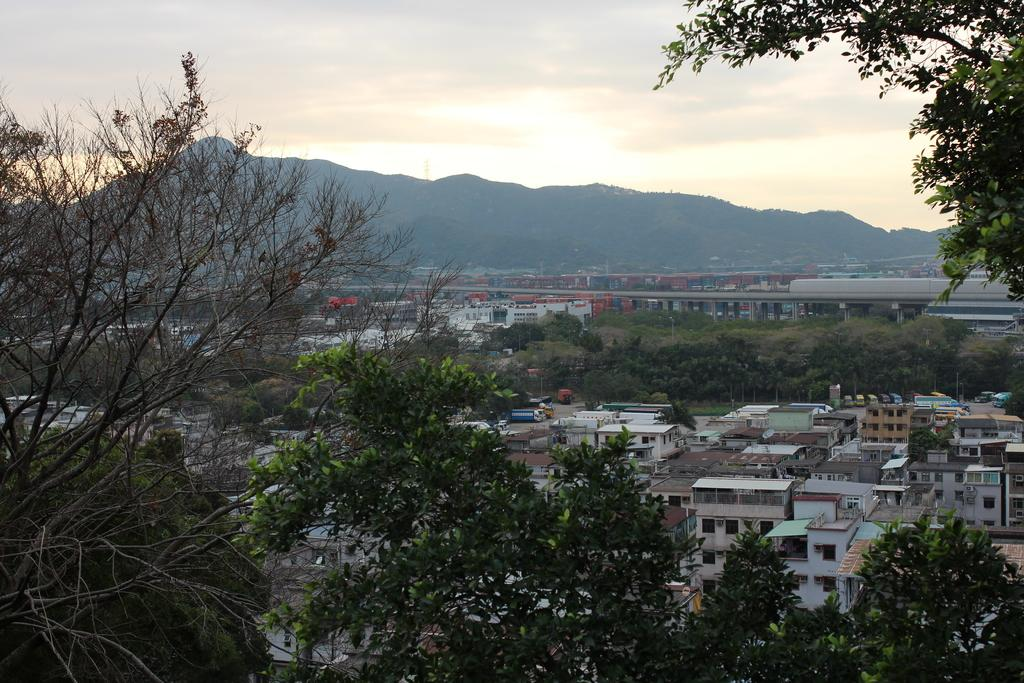What type of natural elements can be seen in the image? There are trees in the image. What type of man-made structures are present in the image? There are houses and a bridge in the image. What can be seen in the distance in the image? There are hills visible in the background of the image. What is visible in the sky in the image? The sky is visible in the background of the image. Is there any quicksand visible in the image? There is no quicksand present in the image. How is the distribution of trees and houses in the image? The distribution of trees and houses cannot be determined from the image alone, as it only provides a snapshot of the scene. 